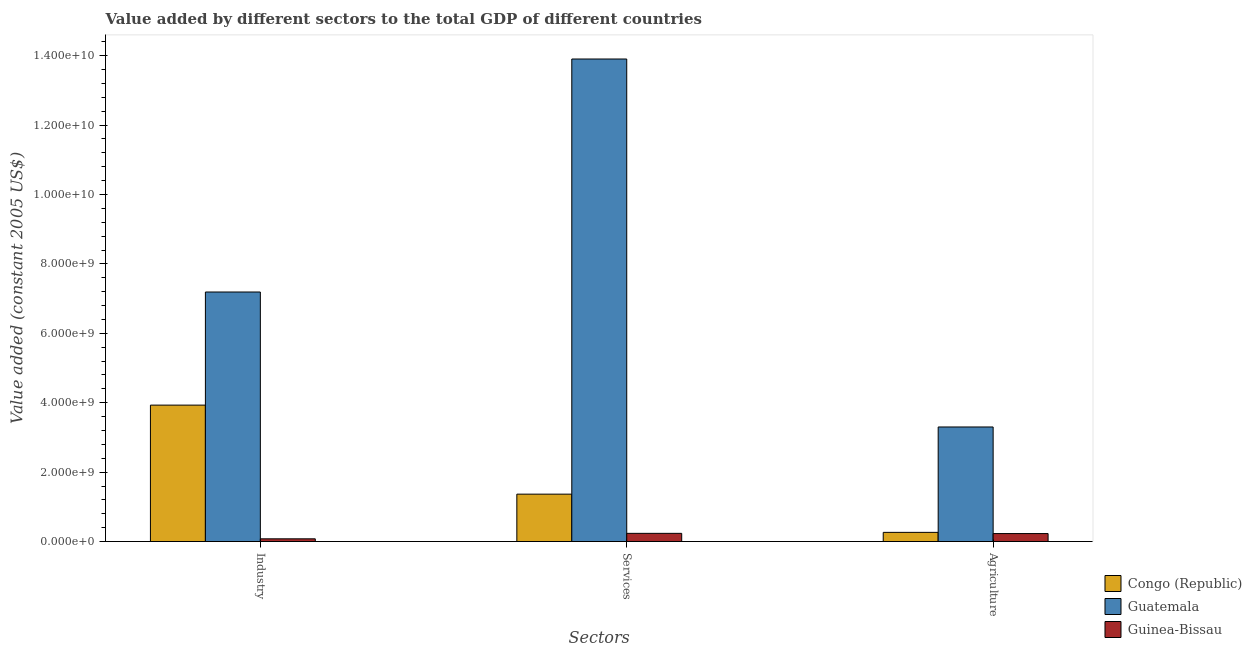How many different coloured bars are there?
Offer a terse response. 3. Are the number of bars per tick equal to the number of legend labels?
Give a very brief answer. Yes. What is the label of the 2nd group of bars from the left?
Your response must be concise. Services. What is the value added by industrial sector in Congo (Republic)?
Keep it short and to the point. 3.93e+09. Across all countries, what is the maximum value added by agricultural sector?
Your answer should be very brief. 3.30e+09. Across all countries, what is the minimum value added by agricultural sector?
Your answer should be compact. 2.30e+08. In which country was the value added by industrial sector maximum?
Offer a very short reply. Guatemala. In which country was the value added by agricultural sector minimum?
Offer a terse response. Guinea-Bissau. What is the total value added by agricultural sector in the graph?
Your answer should be very brief. 3.80e+09. What is the difference between the value added by services in Guatemala and that in Guinea-Bissau?
Your answer should be compact. 1.37e+1. What is the difference between the value added by services in Congo (Republic) and the value added by agricultural sector in Guinea-Bissau?
Offer a very short reply. 1.14e+09. What is the average value added by agricultural sector per country?
Provide a short and direct response. 1.27e+09. What is the difference between the value added by agricultural sector and value added by industrial sector in Guatemala?
Your response must be concise. -3.89e+09. What is the ratio of the value added by industrial sector in Congo (Republic) to that in Guinea-Bissau?
Keep it short and to the point. 49.86. What is the difference between the highest and the second highest value added by services?
Provide a short and direct response. 1.25e+1. What is the difference between the highest and the lowest value added by agricultural sector?
Provide a succinct answer. 3.07e+09. In how many countries, is the value added by agricultural sector greater than the average value added by agricultural sector taken over all countries?
Your response must be concise. 1. What does the 1st bar from the left in Services represents?
Provide a short and direct response. Congo (Republic). What does the 3rd bar from the right in Agriculture represents?
Ensure brevity in your answer.  Congo (Republic). Is it the case that in every country, the sum of the value added by industrial sector and value added by services is greater than the value added by agricultural sector?
Your answer should be very brief. Yes. How many bars are there?
Offer a very short reply. 9. How many countries are there in the graph?
Provide a succinct answer. 3. Are the values on the major ticks of Y-axis written in scientific E-notation?
Your response must be concise. Yes. Does the graph contain grids?
Give a very brief answer. No. Where does the legend appear in the graph?
Give a very brief answer. Bottom right. What is the title of the graph?
Keep it short and to the point. Value added by different sectors to the total GDP of different countries. Does "Latvia" appear as one of the legend labels in the graph?
Provide a succinct answer. No. What is the label or title of the X-axis?
Your answer should be compact. Sectors. What is the label or title of the Y-axis?
Provide a short and direct response. Value added (constant 2005 US$). What is the Value added (constant 2005 US$) of Congo (Republic) in Industry?
Your answer should be very brief. 3.93e+09. What is the Value added (constant 2005 US$) of Guatemala in Industry?
Your answer should be very brief. 7.19e+09. What is the Value added (constant 2005 US$) in Guinea-Bissau in Industry?
Your response must be concise. 7.88e+07. What is the Value added (constant 2005 US$) in Congo (Republic) in Services?
Your answer should be very brief. 1.37e+09. What is the Value added (constant 2005 US$) of Guatemala in Services?
Your response must be concise. 1.39e+1. What is the Value added (constant 2005 US$) in Guinea-Bissau in Services?
Your response must be concise. 2.37e+08. What is the Value added (constant 2005 US$) of Congo (Republic) in Agriculture?
Your answer should be very brief. 2.65e+08. What is the Value added (constant 2005 US$) in Guatemala in Agriculture?
Keep it short and to the point. 3.30e+09. What is the Value added (constant 2005 US$) of Guinea-Bissau in Agriculture?
Give a very brief answer. 2.30e+08. Across all Sectors, what is the maximum Value added (constant 2005 US$) of Congo (Republic)?
Your answer should be compact. 3.93e+09. Across all Sectors, what is the maximum Value added (constant 2005 US$) of Guatemala?
Your answer should be very brief. 1.39e+1. Across all Sectors, what is the maximum Value added (constant 2005 US$) of Guinea-Bissau?
Your answer should be compact. 2.37e+08. Across all Sectors, what is the minimum Value added (constant 2005 US$) in Congo (Republic)?
Offer a terse response. 2.65e+08. Across all Sectors, what is the minimum Value added (constant 2005 US$) in Guatemala?
Your answer should be compact. 3.30e+09. Across all Sectors, what is the minimum Value added (constant 2005 US$) in Guinea-Bissau?
Your response must be concise. 7.88e+07. What is the total Value added (constant 2005 US$) in Congo (Republic) in the graph?
Offer a very short reply. 5.56e+09. What is the total Value added (constant 2005 US$) of Guatemala in the graph?
Your response must be concise. 2.44e+1. What is the total Value added (constant 2005 US$) of Guinea-Bissau in the graph?
Make the answer very short. 5.46e+08. What is the difference between the Value added (constant 2005 US$) of Congo (Republic) in Industry and that in Services?
Give a very brief answer. 2.57e+09. What is the difference between the Value added (constant 2005 US$) in Guatemala in Industry and that in Services?
Provide a short and direct response. -6.71e+09. What is the difference between the Value added (constant 2005 US$) in Guinea-Bissau in Industry and that in Services?
Offer a very short reply. -1.58e+08. What is the difference between the Value added (constant 2005 US$) of Congo (Republic) in Industry and that in Agriculture?
Make the answer very short. 3.67e+09. What is the difference between the Value added (constant 2005 US$) in Guatemala in Industry and that in Agriculture?
Your answer should be very brief. 3.89e+09. What is the difference between the Value added (constant 2005 US$) in Guinea-Bissau in Industry and that in Agriculture?
Keep it short and to the point. -1.52e+08. What is the difference between the Value added (constant 2005 US$) in Congo (Republic) in Services and that in Agriculture?
Provide a succinct answer. 1.10e+09. What is the difference between the Value added (constant 2005 US$) of Guatemala in Services and that in Agriculture?
Make the answer very short. 1.06e+1. What is the difference between the Value added (constant 2005 US$) in Guinea-Bissau in Services and that in Agriculture?
Provide a short and direct response. 6.11e+06. What is the difference between the Value added (constant 2005 US$) in Congo (Republic) in Industry and the Value added (constant 2005 US$) in Guatemala in Services?
Ensure brevity in your answer.  -9.97e+09. What is the difference between the Value added (constant 2005 US$) of Congo (Republic) in Industry and the Value added (constant 2005 US$) of Guinea-Bissau in Services?
Provide a short and direct response. 3.69e+09. What is the difference between the Value added (constant 2005 US$) of Guatemala in Industry and the Value added (constant 2005 US$) of Guinea-Bissau in Services?
Offer a very short reply. 6.95e+09. What is the difference between the Value added (constant 2005 US$) in Congo (Republic) in Industry and the Value added (constant 2005 US$) in Guatemala in Agriculture?
Your answer should be compact. 6.30e+08. What is the difference between the Value added (constant 2005 US$) in Congo (Republic) in Industry and the Value added (constant 2005 US$) in Guinea-Bissau in Agriculture?
Provide a succinct answer. 3.70e+09. What is the difference between the Value added (constant 2005 US$) in Guatemala in Industry and the Value added (constant 2005 US$) in Guinea-Bissau in Agriculture?
Offer a very short reply. 6.96e+09. What is the difference between the Value added (constant 2005 US$) in Congo (Republic) in Services and the Value added (constant 2005 US$) in Guatemala in Agriculture?
Provide a succinct answer. -1.94e+09. What is the difference between the Value added (constant 2005 US$) in Congo (Republic) in Services and the Value added (constant 2005 US$) in Guinea-Bissau in Agriculture?
Offer a very short reply. 1.14e+09. What is the difference between the Value added (constant 2005 US$) in Guatemala in Services and the Value added (constant 2005 US$) in Guinea-Bissau in Agriculture?
Your answer should be very brief. 1.37e+1. What is the average Value added (constant 2005 US$) in Congo (Republic) per Sectors?
Provide a short and direct response. 1.85e+09. What is the average Value added (constant 2005 US$) of Guatemala per Sectors?
Keep it short and to the point. 8.13e+09. What is the average Value added (constant 2005 US$) of Guinea-Bissau per Sectors?
Your answer should be very brief. 1.82e+08. What is the difference between the Value added (constant 2005 US$) in Congo (Republic) and Value added (constant 2005 US$) in Guatemala in Industry?
Ensure brevity in your answer.  -3.26e+09. What is the difference between the Value added (constant 2005 US$) in Congo (Republic) and Value added (constant 2005 US$) in Guinea-Bissau in Industry?
Your answer should be compact. 3.85e+09. What is the difference between the Value added (constant 2005 US$) of Guatemala and Value added (constant 2005 US$) of Guinea-Bissau in Industry?
Provide a short and direct response. 7.11e+09. What is the difference between the Value added (constant 2005 US$) in Congo (Republic) and Value added (constant 2005 US$) in Guatemala in Services?
Your answer should be compact. -1.25e+1. What is the difference between the Value added (constant 2005 US$) in Congo (Republic) and Value added (constant 2005 US$) in Guinea-Bissau in Services?
Offer a very short reply. 1.13e+09. What is the difference between the Value added (constant 2005 US$) of Guatemala and Value added (constant 2005 US$) of Guinea-Bissau in Services?
Your response must be concise. 1.37e+1. What is the difference between the Value added (constant 2005 US$) of Congo (Republic) and Value added (constant 2005 US$) of Guatemala in Agriculture?
Offer a very short reply. -3.04e+09. What is the difference between the Value added (constant 2005 US$) in Congo (Republic) and Value added (constant 2005 US$) in Guinea-Bissau in Agriculture?
Your answer should be compact. 3.45e+07. What is the difference between the Value added (constant 2005 US$) in Guatemala and Value added (constant 2005 US$) in Guinea-Bissau in Agriculture?
Provide a short and direct response. 3.07e+09. What is the ratio of the Value added (constant 2005 US$) of Congo (Republic) in Industry to that in Services?
Provide a short and direct response. 2.88. What is the ratio of the Value added (constant 2005 US$) of Guatemala in Industry to that in Services?
Give a very brief answer. 0.52. What is the ratio of the Value added (constant 2005 US$) in Guinea-Bissau in Industry to that in Services?
Offer a terse response. 0.33. What is the ratio of the Value added (constant 2005 US$) of Congo (Republic) in Industry to that in Agriculture?
Your answer should be very brief. 14.84. What is the ratio of the Value added (constant 2005 US$) of Guatemala in Industry to that in Agriculture?
Offer a terse response. 2.18. What is the ratio of the Value added (constant 2005 US$) in Guinea-Bissau in Industry to that in Agriculture?
Your answer should be compact. 0.34. What is the ratio of the Value added (constant 2005 US$) in Congo (Republic) in Services to that in Agriculture?
Your response must be concise. 5.16. What is the ratio of the Value added (constant 2005 US$) of Guatemala in Services to that in Agriculture?
Provide a short and direct response. 4.21. What is the ratio of the Value added (constant 2005 US$) in Guinea-Bissau in Services to that in Agriculture?
Ensure brevity in your answer.  1.03. What is the difference between the highest and the second highest Value added (constant 2005 US$) in Congo (Republic)?
Offer a very short reply. 2.57e+09. What is the difference between the highest and the second highest Value added (constant 2005 US$) of Guatemala?
Your answer should be very brief. 6.71e+09. What is the difference between the highest and the second highest Value added (constant 2005 US$) in Guinea-Bissau?
Your response must be concise. 6.11e+06. What is the difference between the highest and the lowest Value added (constant 2005 US$) of Congo (Republic)?
Provide a short and direct response. 3.67e+09. What is the difference between the highest and the lowest Value added (constant 2005 US$) in Guatemala?
Your answer should be very brief. 1.06e+1. What is the difference between the highest and the lowest Value added (constant 2005 US$) in Guinea-Bissau?
Your answer should be compact. 1.58e+08. 